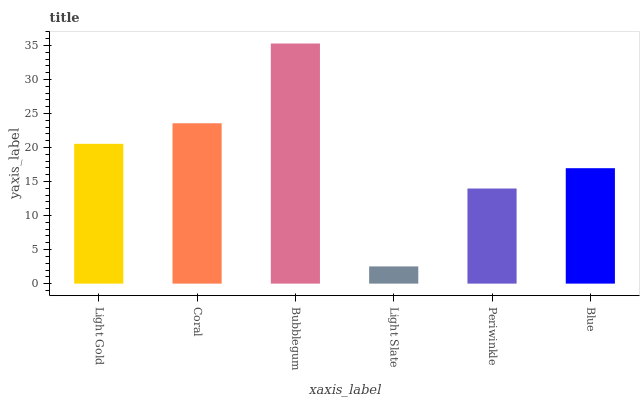Is Light Slate the minimum?
Answer yes or no. Yes. Is Bubblegum the maximum?
Answer yes or no. Yes. Is Coral the minimum?
Answer yes or no. No. Is Coral the maximum?
Answer yes or no. No. Is Coral greater than Light Gold?
Answer yes or no. Yes. Is Light Gold less than Coral?
Answer yes or no. Yes. Is Light Gold greater than Coral?
Answer yes or no. No. Is Coral less than Light Gold?
Answer yes or no. No. Is Light Gold the high median?
Answer yes or no. Yes. Is Blue the low median?
Answer yes or no. Yes. Is Coral the high median?
Answer yes or no. No. Is Light Gold the low median?
Answer yes or no. No. 